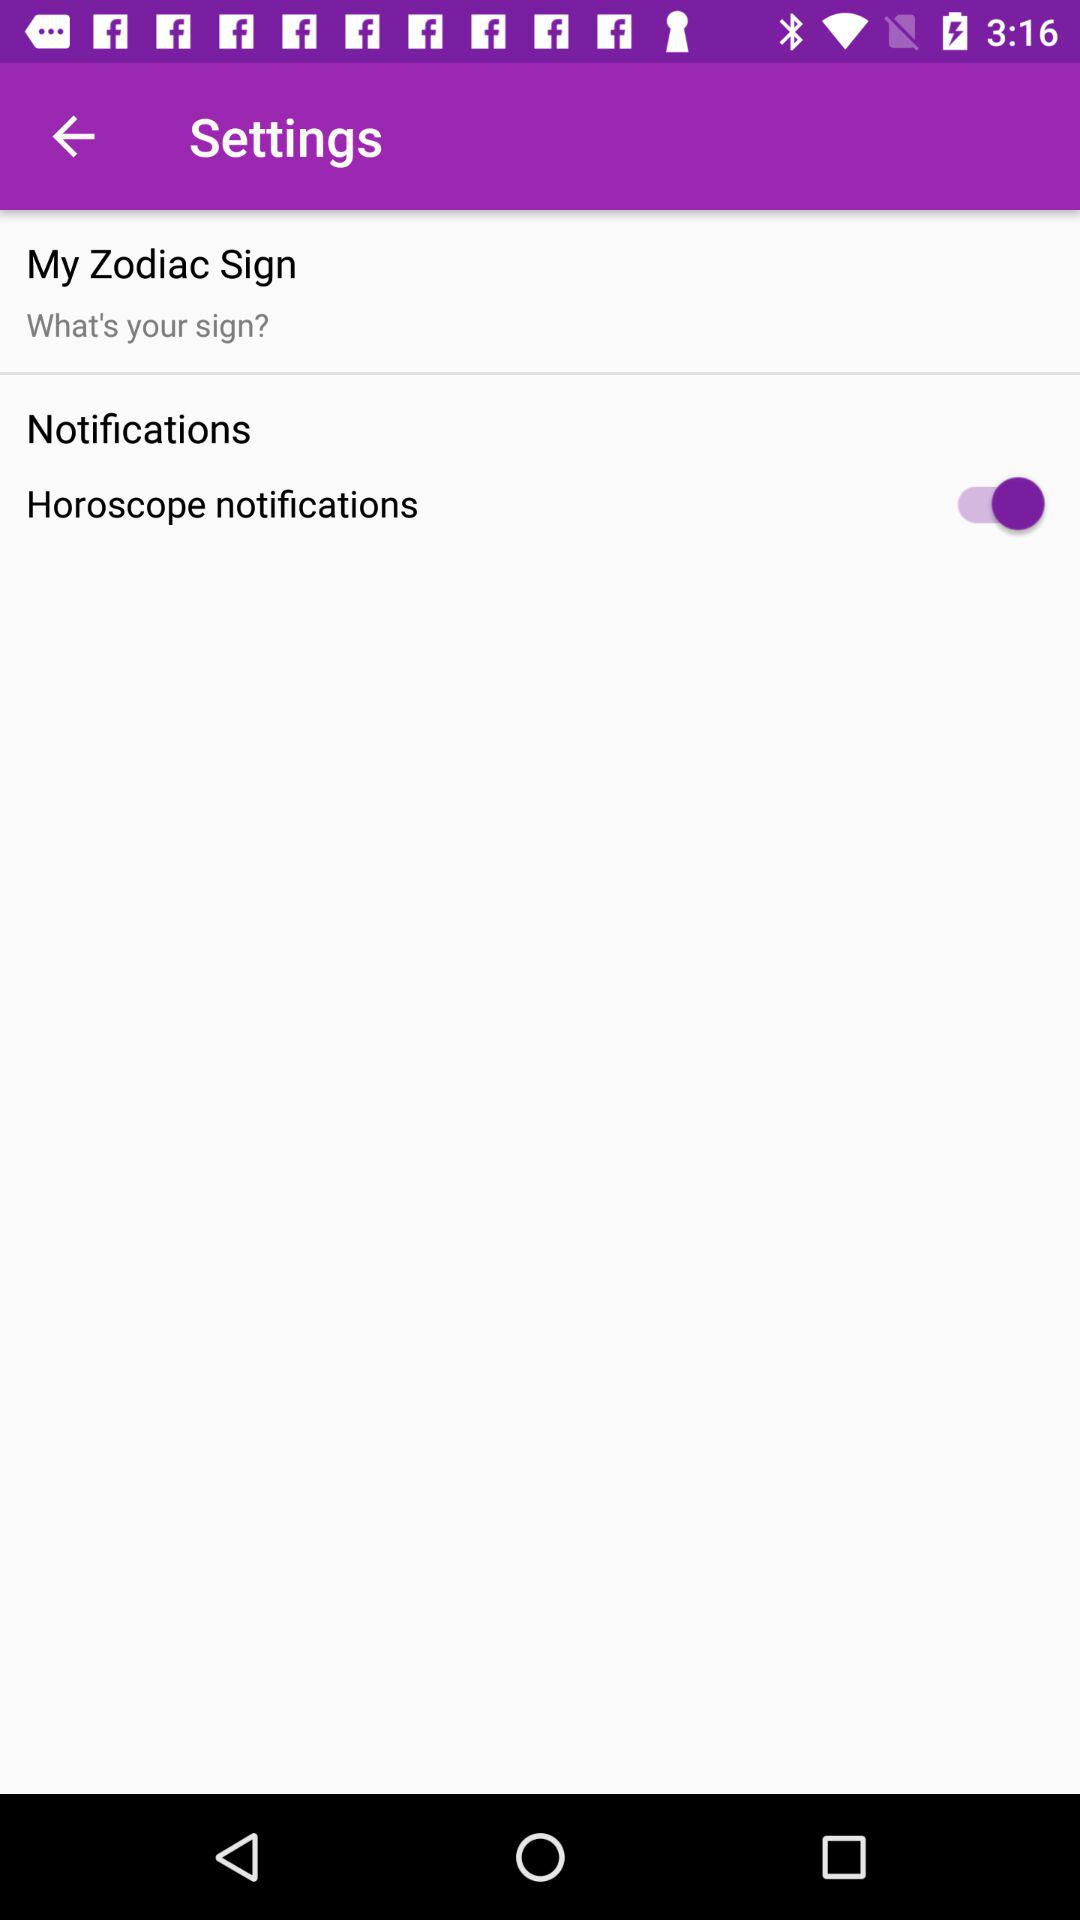Which zodiac sign is selected?
When the provided information is insufficient, respond with <no answer>. <no answer> 